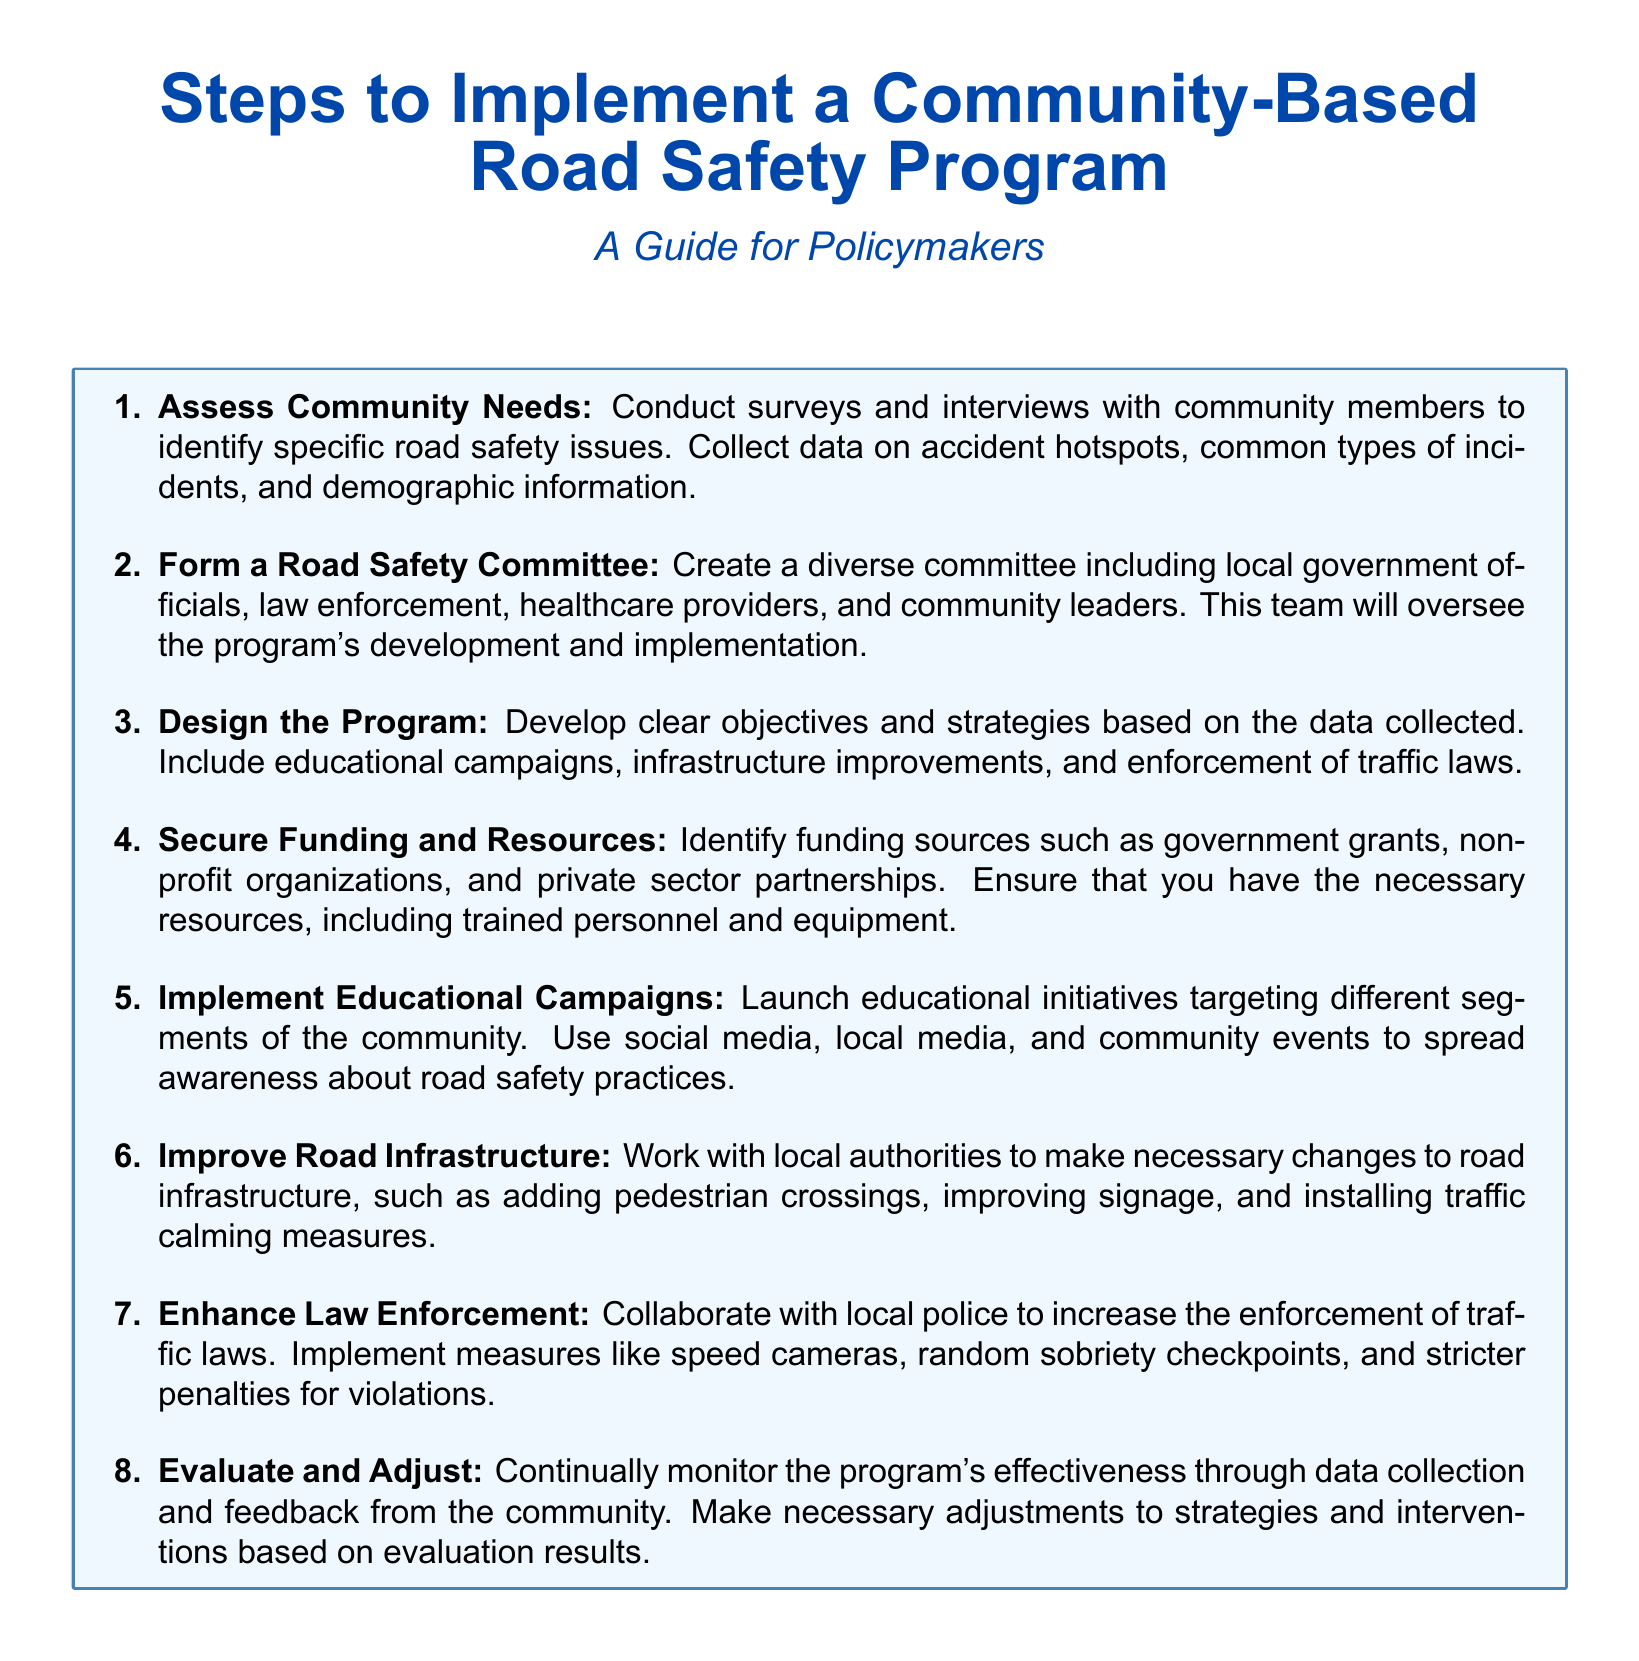what is the first step in the program? The first step involves assessing community needs by conducting surveys and interviews with community members.
Answer: Assess Community Needs how many members should be included in the Road Safety Committee? The document suggests creating a diverse committee, but does not specify a number.
Answer: Diverse committee which stakeholders are suggested to be part of the Road Safety Committee? The stakeholders include local government officials, law enforcement, healthcare providers, and community leaders.
Answer: Local government, law enforcement, healthcare providers, community leaders what is the purpose of securing funding and resources? The purpose is to ensure that necessary resources, including trained personnel and equipment, are available for the program.
Answer: Necessary resources how should educational campaigns be launched? Educational campaigns should target different segments of the community using social media, local media, and community events.
Answer: Social media, local media, community events what is the seventh step in the program? The seventh step involves enhancing law enforcement to increase the enforcement of traffic laws.
Answer: Enhance Law Enforcement how will the program's effectiveness be monitored? The program's effectiveness will be monitored through data collection and feedback from the community.
Answer: Data collection, feedback what is the last step in the Road Safety Program? The last step involves evaluating and adjusting the program based on effectiveness results.
Answer: Evaluate and Adjust 